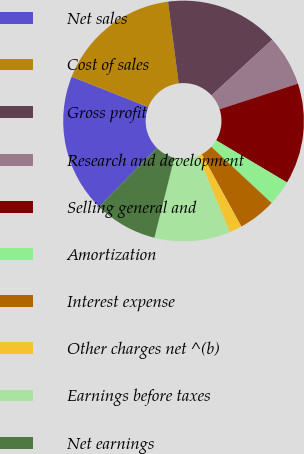Convert chart. <chart><loc_0><loc_0><loc_500><loc_500><pie_chart><fcel>Net sales<fcel>Cost of sales<fcel>Gross profit<fcel>Research and development<fcel>Selling general and<fcel>Amortization<fcel>Interest expense<fcel>Other charges net ^(b)<fcel>Earnings before taxes<fcel>Net earnings<nl><fcel>18.63%<fcel>16.94%<fcel>15.25%<fcel>6.78%<fcel>13.56%<fcel>3.4%<fcel>5.09%<fcel>1.7%<fcel>10.17%<fcel>8.48%<nl></chart> 